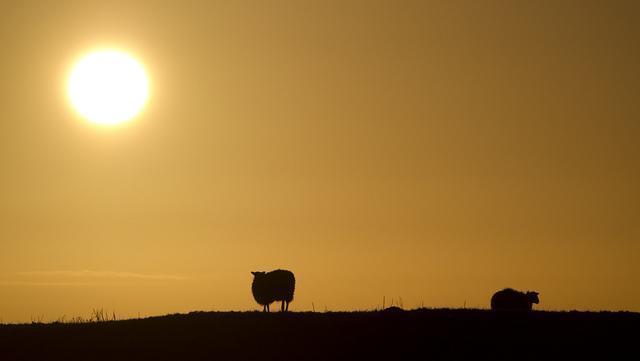How many animals are there?
Give a very brief answer. 2. 